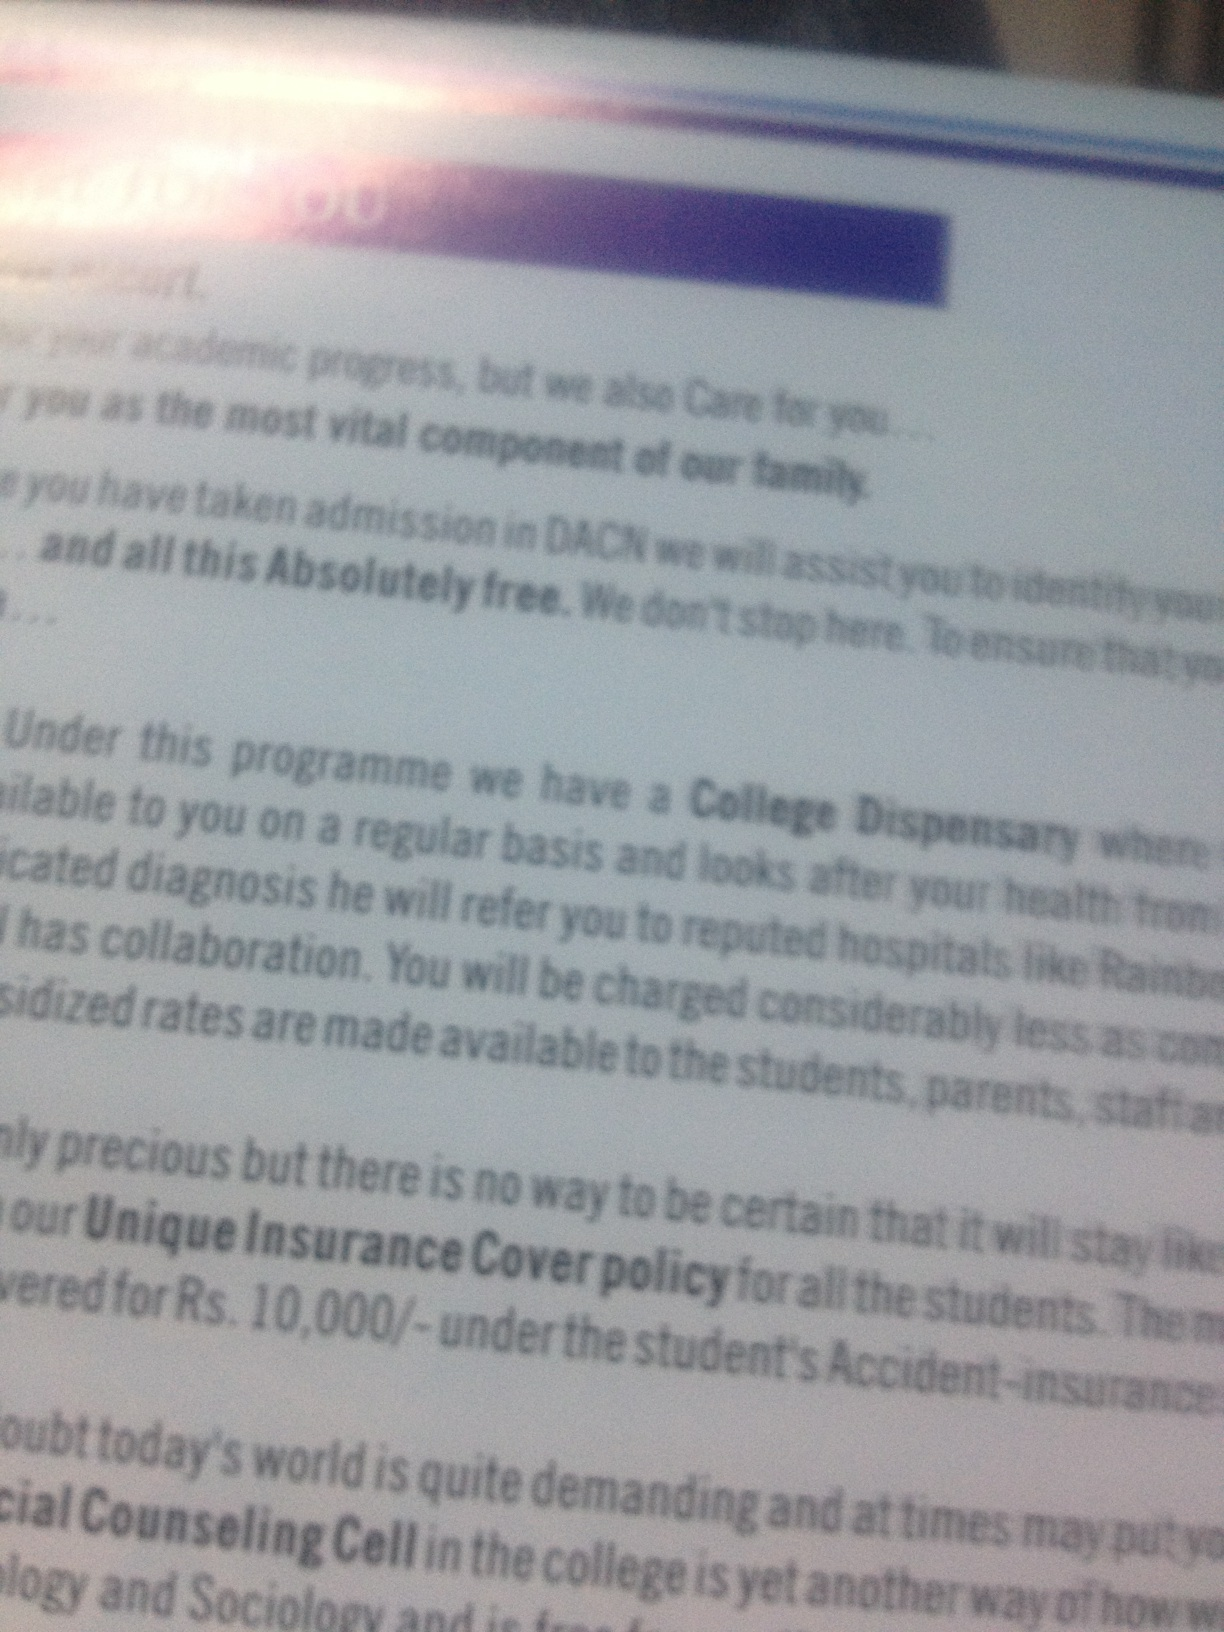Hey, what text can you read on the page in this picture? The page contains the following text in parts: '...your academic progress, but we also Care for you... most vital component of our family... admitted in DACN we will assist you... absolutely free... College Dispensary... regular basis... reputed hospitals like... Rs. 10,000/-... Social Counseling...' The full text is not completely clear due to blurriness, but it appears to be about student support services, including health care and insurance policies. 